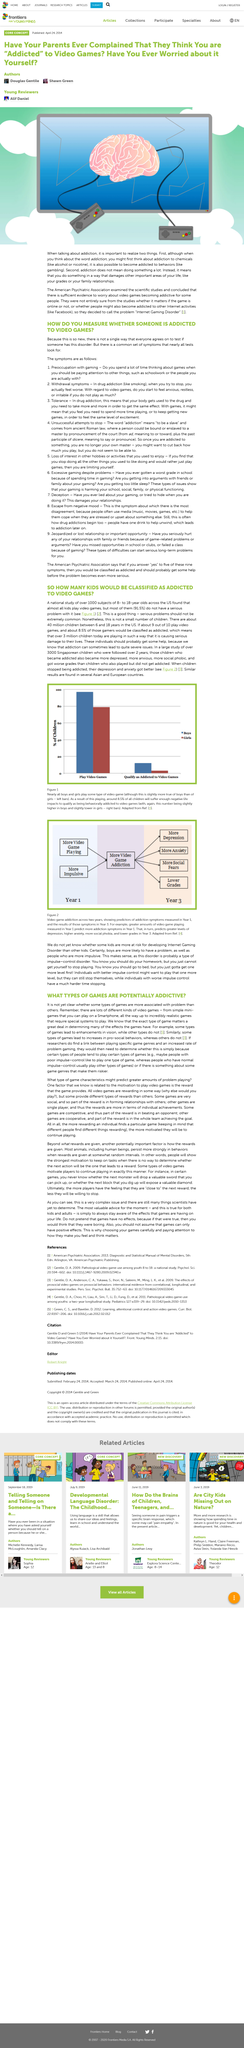Identify some key points in this picture. It is well known that the reward that a video game provides is a significant factor that contributes to the motivation to play. Deception damages relationships, as it undermines trust and respect, causing individuals to feel betrayed and hurt, leading to a breakdown in communication and a decline in the quality of their relationships. I declare that the word 'addiction' originates from ancient Roman law. The United States contains approximately 40 million children between the ages of 8 and 18. According to the survey, approximately 8.5% of children are classified as addicted. 